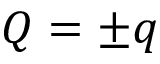<formula> <loc_0><loc_0><loc_500><loc_500>Q = \pm q</formula> 